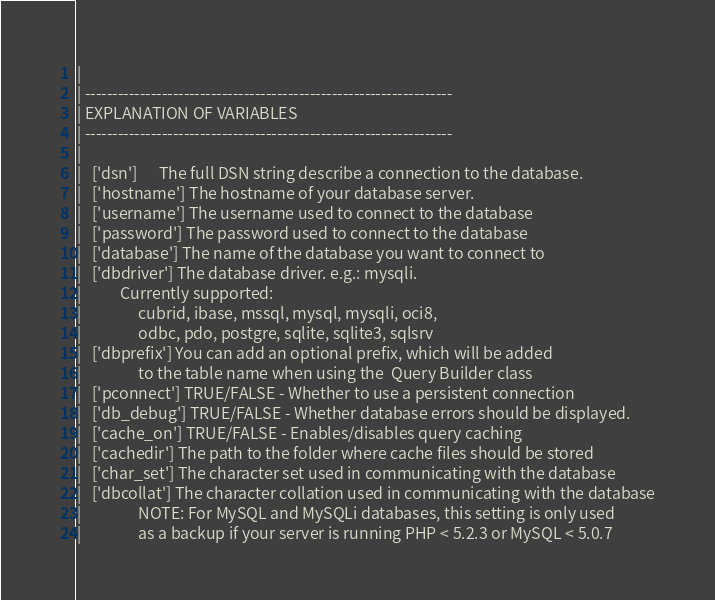Convert code to text. <code><loc_0><loc_0><loc_500><loc_500><_PHP_>|
| -------------------------------------------------------------------
| EXPLANATION OF VARIABLES
| -------------------------------------------------------------------
|
|	['dsn']      The full DSN string describe a connection to the database.
|	['hostname'] The hostname of your database server.
|	['username'] The username used to connect to the database
|	['password'] The password used to connect to the database
|	['database'] The name of the database you want to connect to
|	['dbdriver'] The database driver. e.g.: mysqli.
|			Currently supported:
|				 cubrid, ibase, mssql, mysql, mysqli, oci8,
|				 odbc, pdo, postgre, sqlite, sqlite3, sqlsrv
|	['dbprefix'] You can add an optional prefix, which will be added
|				 to the table name when using the  Query Builder class
|	['pconnect'] TRUE/FALSE - Whether to use a persistent connection
|	['db_debug'] TRUE/FALSE - Whether database errors should be displayed.
|	['cache_on'] TRUE/FALSE - Enables/disables query caching
|	['cachedir'] The path to the folder where cache files should be stored
|	['char_set'] The character set used in communicating with the database
|	['dbcollat'] The character collation used in communicating with the database
|				 NOTE: For MySQL and MySQLi databases, this setting is only used
| 				 as a backup if your server is running PHP < 5.2.3 or MySQL < 5.0.7</code> 